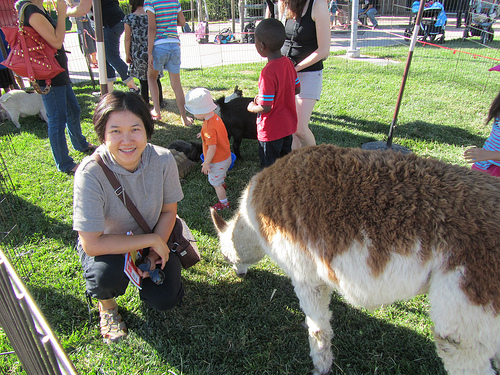Please provide a short description for this region: [0.36, 0.29, 0.44, 0.36]. The region highlights a white hat that the boy is wearing, adding a distinct detail to his outfit. 